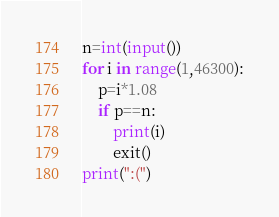Convert code to text. <code><loc_0><loc_0><loc_500><loc_500><_Python_>n=int(input())
for i in range(1,46300):
	p=i*1.08
	if p==n:
	    print(i)
	    exit()
print(":(")</code> 